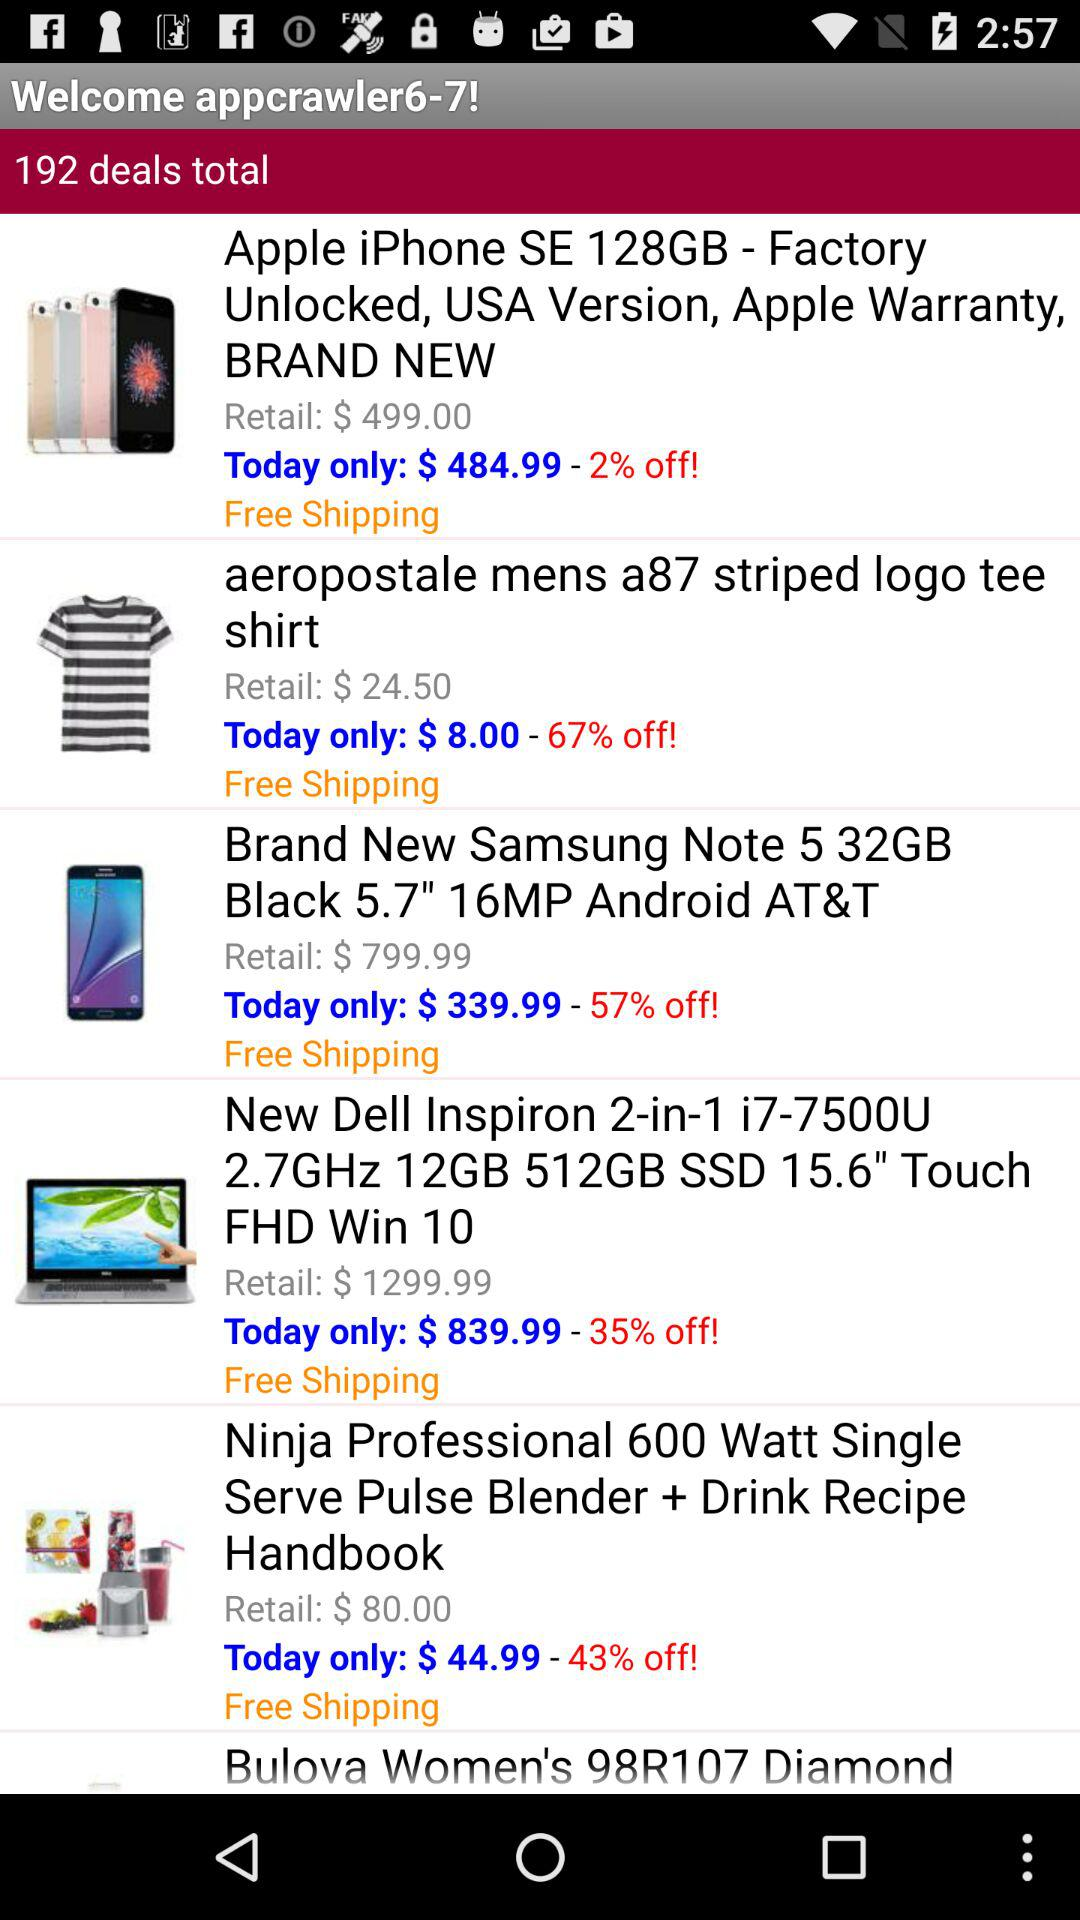What is the price of "Apple iPhone SE" for today? The price of "Apple iPhone SE" for today is $484.99. 